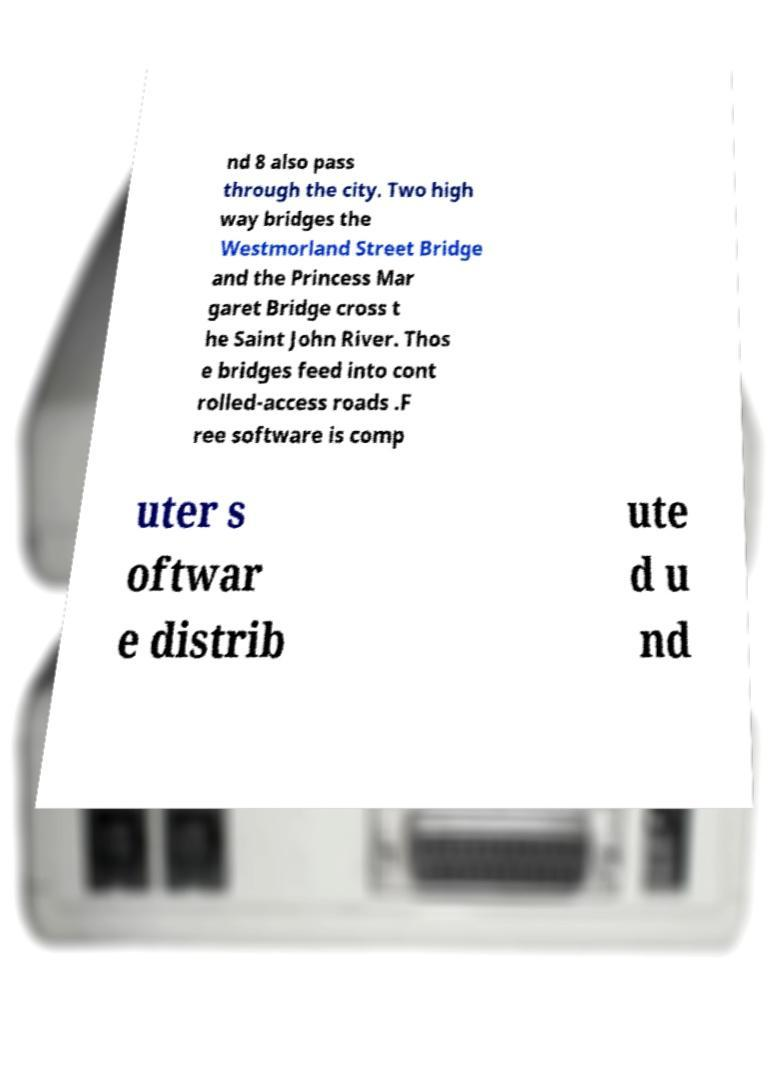Could you extract and type out the text from this image? nd 8 also pass through the city. Two high way bridges the Westmorland Street Bridge and the Princess Mar garet Bridge cross t he Saint John River. Thos e bridges feed into cont rolled-access roads .F ree software is comp uter s oftwar e distrib ute d u nd 